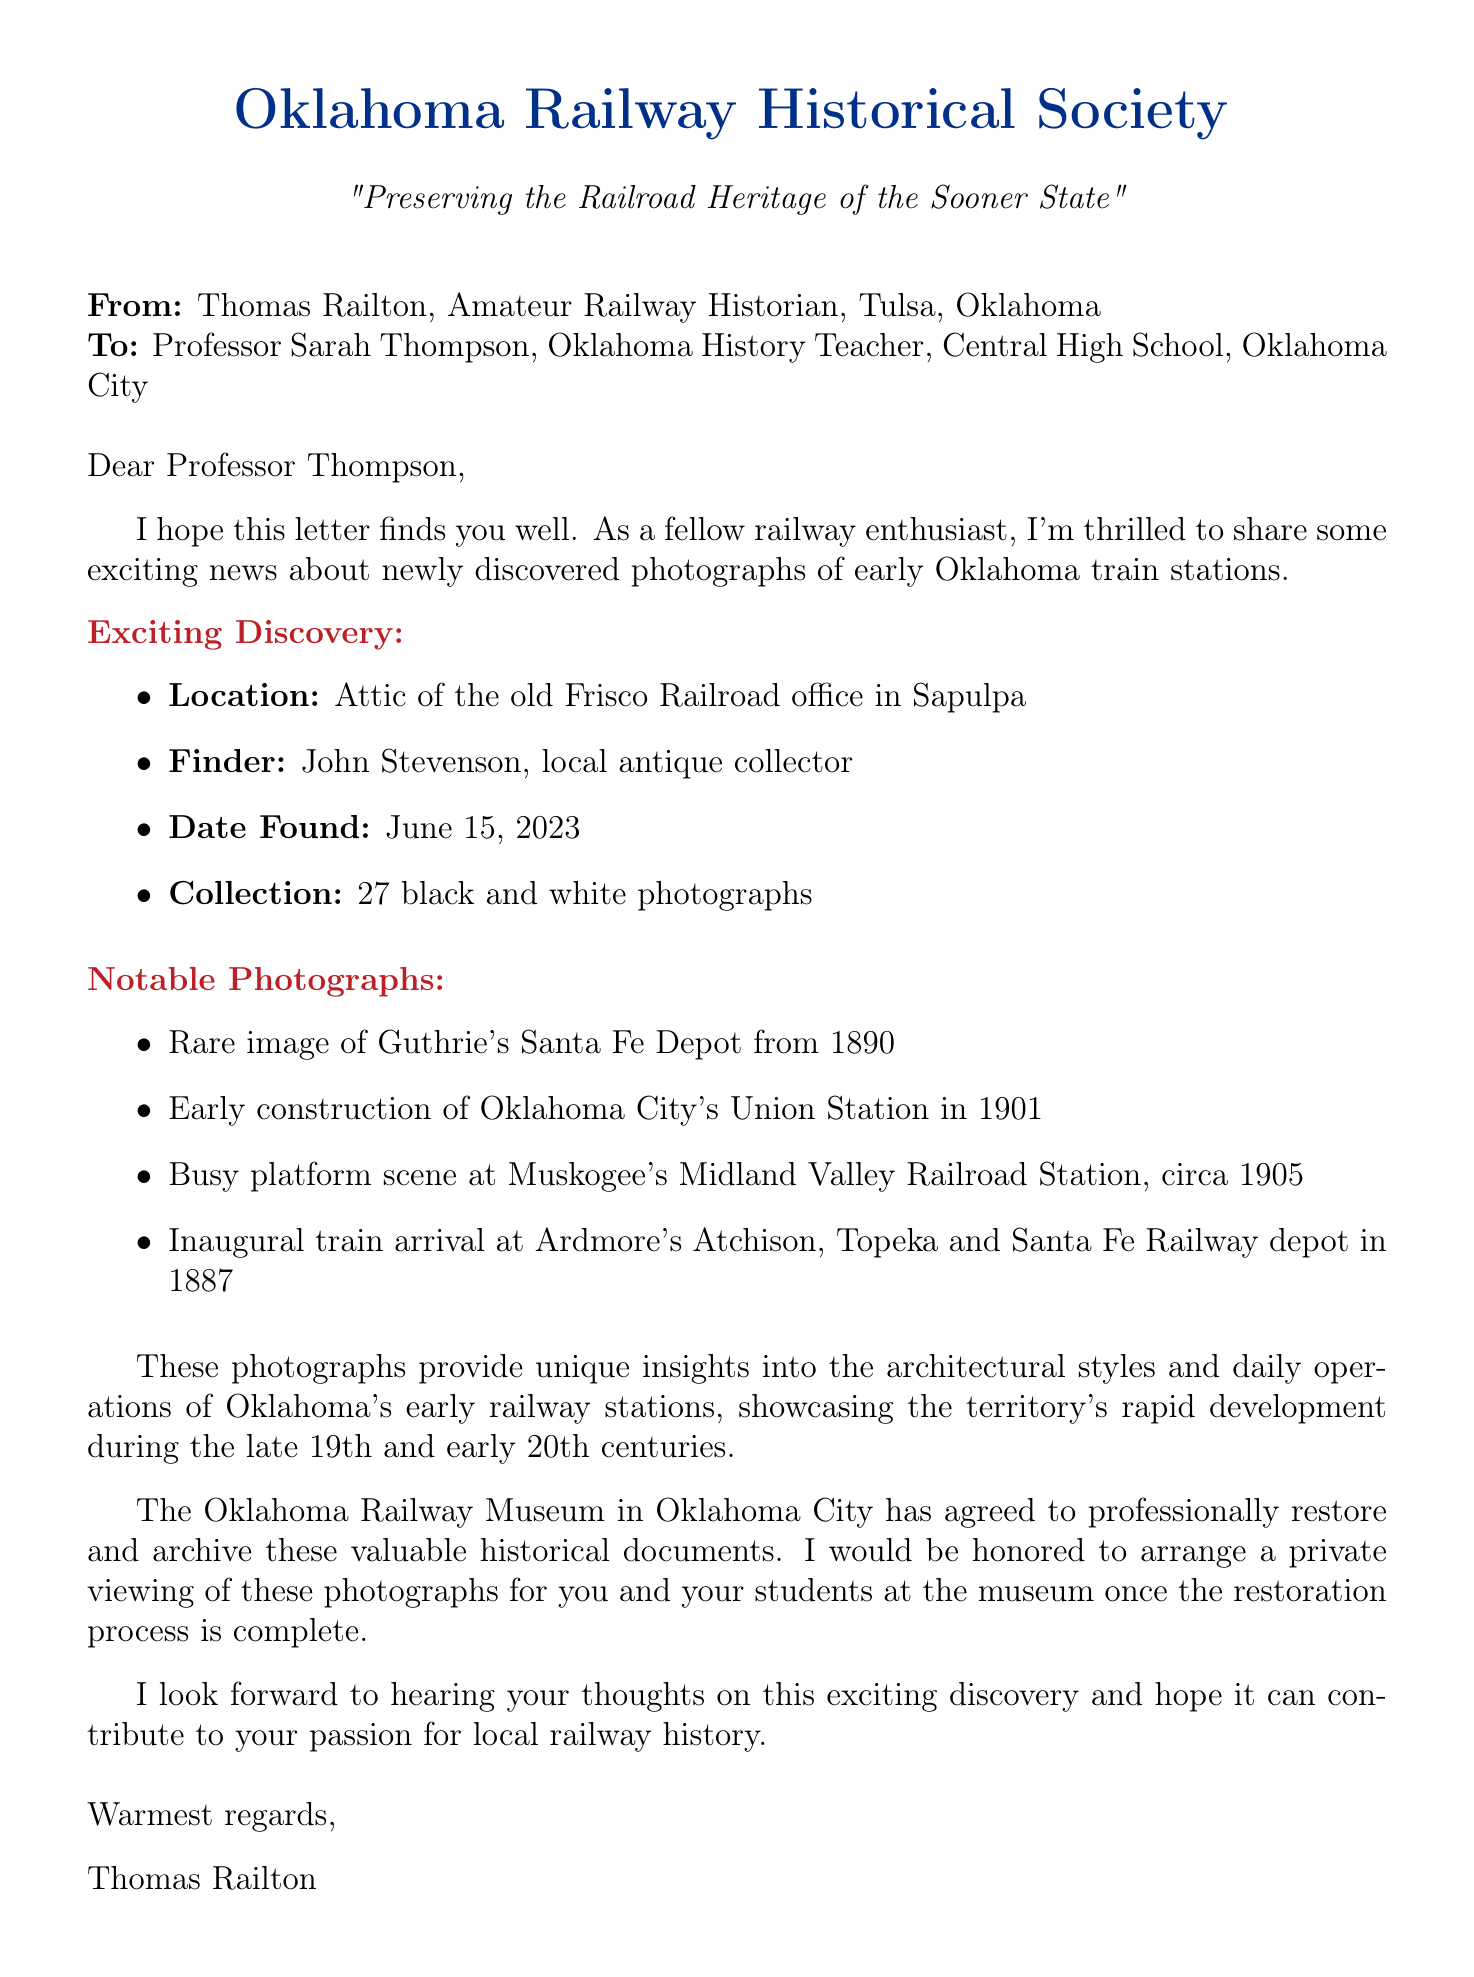What is the name of the sender? The sender's name is mentioned at the beginning of the document as Thomas Railton.
Answer: Thomas Railton What is the date the photographs were found? The date found is specified in the document as June 15, 2023.
Answer: June 15, 2023 How many photographs were discovered? The total number of photographs discovered is listed as 27 black and white photographs.
Answer: 27 black and white photographs What is the historical significance of the photographs? The document states that the photographs provide unique insights into the architectural styles and daily operations of Oklahoma's early railway stations.
Answer: Unique insights into architectural styles and daily operations Who agreed to restore and archive the photographs? The organization mentioned in the document that agreed to restore and archive the photographs is the Oklahoma Railway Museum.
Answer: Oklahoma Railway Museum What does Thomas Railton invite Professor Thompson to do? The invitation from Thomas Railton in the document is to arrange a private viewing of the photographs for Professor Thompson and her students.
Answer: Arrange a private viewing of the photographs What is the location where the photographs were found? The location is specified in the letter as the attic of the old Frisco Railroad office in Sapulpa.
Answer: Attic of the old Frisco Railroad office in Sapulpa What was the occupation of the finder of the photographs? The finder's occupation is described in the document as a local antique collector.
Answer: Local antique collector Which early Oklahoma train station is featured in the 1890 photograph? The photograph features Guthrie's Santa Fe Depot from 1890.
Answer: Guthrie's Santa Fe Depot 